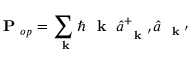<formula> <loc_0><loc_0><loc_500><loc_500>P _ { o p } = \sum _ { k } \hbar { k } \, \hat { a } _ { k ^ { \prime } } ^ { + } \hat { a } _ { k ^ { \prime } }</formula> 